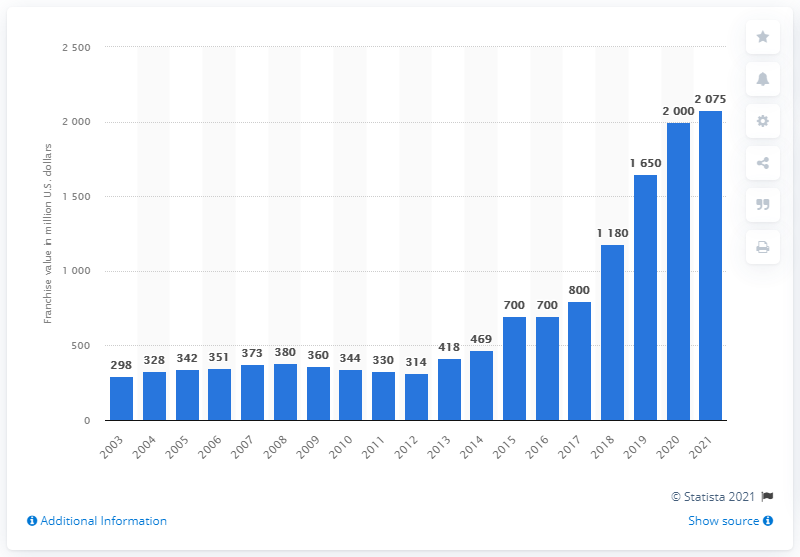Highlight a few significant elements in this photo. As of 2021, the estimated value of the Philadelphia 76ers was approximately 2075. 